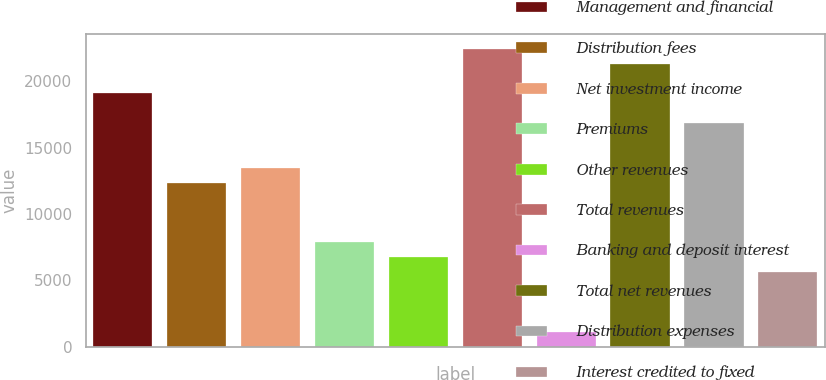Convert chart. <chart><loc_0><loc_0><loc_500><loc_500><bar_chart><fcel>Management and financial<fcel>Distribution fees<fcel>Net investment income<fcel>Premiums<fcel>Other revenues<fcel>Total revenues<fcel>Banking and deposit interest<fcel>Total net revenues<fcel>Distribution expenses<fcel>Interest credited to fixed<nl><fcel>19088.9<fcel>12352.7<fcel>13475.4<fcel>7861.9<fcel>6739.2<fcel>22457<fcel>1125.7<fcel>21334.3<fcel>16843.5<fcel>5616.5<nl></chart> 